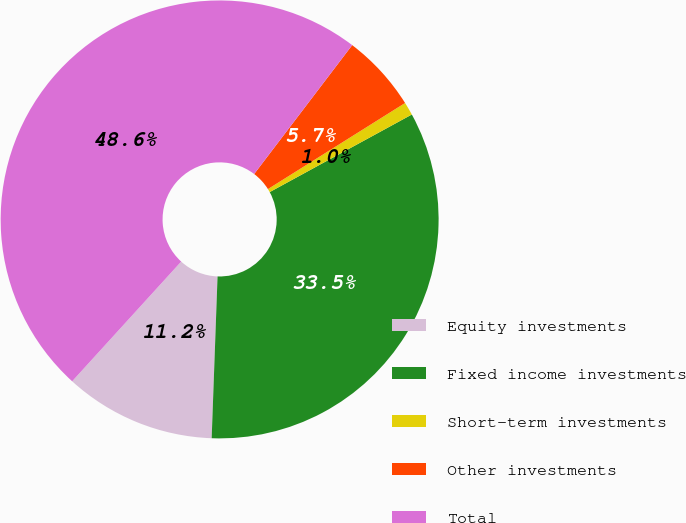<chart> <loc_0><loc_0><loc_500><loc_500><pie_chart><fcel>Equity investments<fcel>Fixed income investments<fcel>Short-term investments<fcel>Other investments<fcel>Total<nl><fcel>11.18%<fcel>33.53%<fcel>0.97%<fcel>5.73%<fcel>48.59%<nl></chart> 